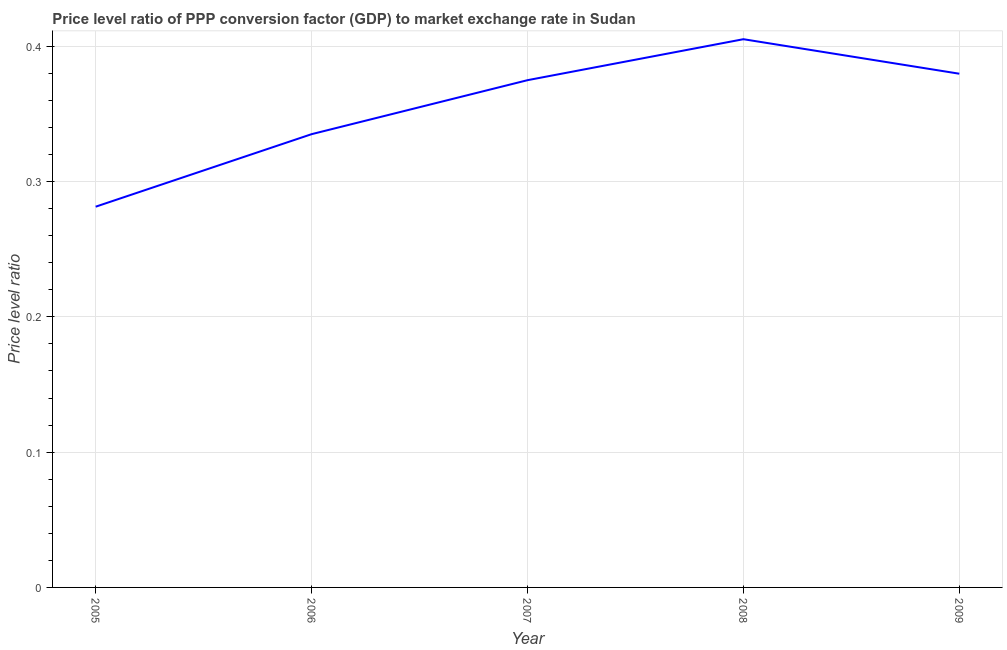What is the price level ratio in 2008?
Provide a succinct answer. 0.41. Across all years, what is the maximum price level ratio?
Your response must be concise. 0.41. Across all years, what is the minimum price level ratio?
Ensure brevity in your answer.  0.28. What is the sum of the price level ratio?
Give a very brief answer. 1.78. What is the difference between the price level ratio in 2008 and 2009?
Provide a short and direct response. 0.03. What is the average price level ratio per year?
Give a very brief answer. 0.36. What is the median price level ratio?
Make the answer very short. 0.37. In how many years, is the price level ratio greater than 0.06 ?
Your answer should be compact. 5. Do a majority of the years between 2006 and 2008 (inclusive) have price level ratio greater than 0.08 ?
Your answer should be very brief. Yes. What is the ratio of the price level ratio in 2007 to that in 2008?
Ensure brevity in your answer.  0.93. Is the price level ratio in 2007 less than that in 2009?
Offer a terse response. Yes. What is the difference between the highest and the second highest price level ratio?
Your answer should be compact. 0.03. Is the sum of the price level ratio in 2006 and 2009 greater than the maximum price level ratio across all years?
Your answer should be compact. Yes. What is the difference between the highest and the lowest price level ratio?
Your answer should be very brief. 0.12. Does the price level ratio monotonically increase over the years?
Keep it short and to the point. No. How many years are there in the graph?
Ensure brevity in your answer.  5. Are the values on the major ticks of Y-axis written in scientific E-notation?
Provide a short and direct response. No. Does the graph contain grids?
Your answer should be compact. Yes. What is the title of the graph?
Offer a very short reply. Price level ratio of PPP conversion factor (GDP) to market exchange rate in Sudan. What is the label or title of the Y-axis?
Ensure brevity in your answer.  Price level ratio. What is the Price level ratio in 2005?
Offer a terse response. 0.28. What is the Price level ratio in 2006?
Keep it short and to the point. 0.34. What is the Price level ratio of 2007?
Your answer should be compact. 0.37. What is the Price level ratio in 2008?
Give a very brief answer. 0.41. What is the Price level ratio in 2009?
Ensure brevity in your answer.  0.38. What is the difference between the Price level ratio in 2005 and 2006?
Your response must be concise. -0.05. What is the difference between the Price level ratio in 2005 and 2007?
Your answer should be compact. -0.09. What is the difference between the Price level ratio in 2005 and 2008?
Your answer should be very brief. -0.12. What is the difference between the Price level ratio in 2005 and 2009?
Give a very brief answer. -0.1. What is the difference between the Price level ratio in 2006 and 2007?
Give a very brief answer. -0.04. What is the difference between the Price level ratio in 2006 and 2008?
Provide a short and direct response. -0.07. What is the difference between the Price level ratio in 2006 and 2009?
Make the answer very short. -0.04. What is the difference between the Price level ratio in 2007 and 2008?
Provide a succinct answer. -0.03. What is the difference between the Price level ratio in 2007 and 2009?
Your response must be concise. -0. What is the difference between the Price level ratio in 2008 and 2009?
Offer a terse response. 0.03. What is the ratio of the Price level ratio in 2005 to that in 2006?
Your response must be concise. 0.84. What is the ratio of the Price level ratio in 2005 to that in 2007?
Offer a very short reply. 0.75. What is the ratio of the Price level ratio in 2005 to that in 2008?
Your answer should be compact. 0.69. What is the ratio of the Price level ratio in 2005 to that in 2009?
Your response must be concise. 0.74. What is the ratio of the Price level ratio in 2006 to that in 2007?
Provide a succinct answer. 0.89. What is the ratio of the Price level ratio in 2006 to that in 2008?
Ensure brevity in your answer.  0.83. What is the ratio of the Price level ratio in 2006 to that in 2009?
Make the answer very short. 0.88. What is the ratio of the Price level ratio in 2007 to that in 2008?
Your answer should be compact. 0.93. What is the ratio of the Price level ratio in 2008 to that in 2009?
Offer a terse response. 1.07. 